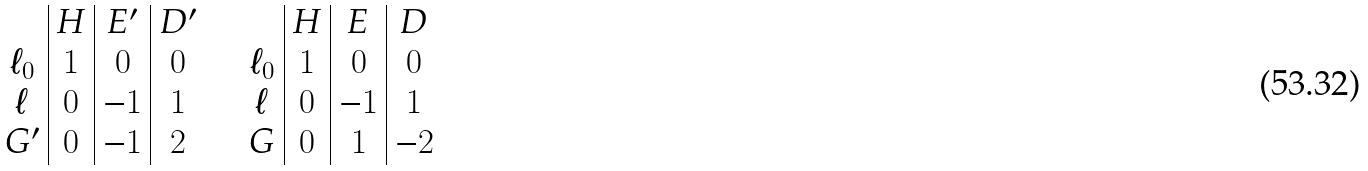<formula> <loc_0><loc_0><loc_500><loc_500>\begin{array} { c | c | c | c } & H & E ^ { \prime } & D ^ { \prime } \\ \ell _ { 0 } & 1 & 0 & 0 \\ \ell & 0 & - 1 & 1 \\ G ^ { \prime } & 0 & - 1 & 2 \end{array} \quad \begin{array} { c | c | c | c } & H & E & D \\ \ell _ { 0 } & 1 & 0 & 0 \\ \ell & 0 & - 1 & 1 \\ G & 0 & 1 & - 2 \end{array}</formula> 